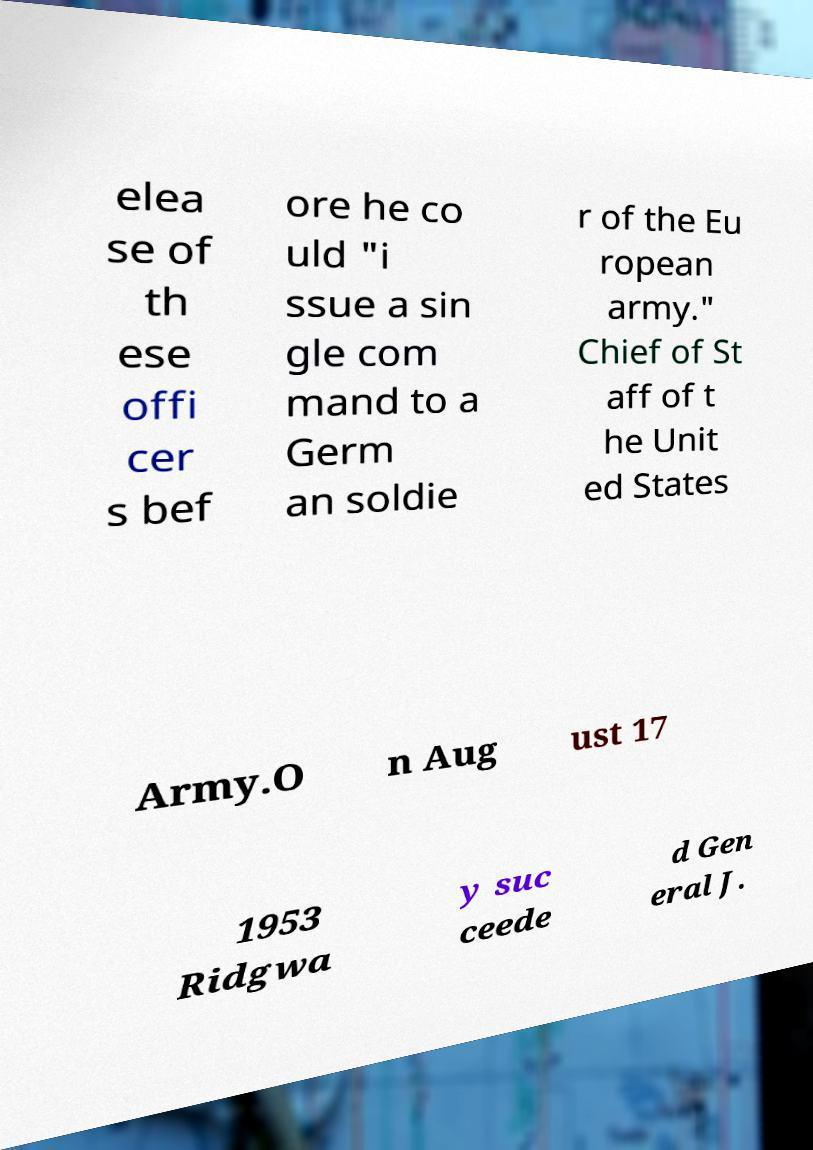What messages or text are displayed in this image? I need them in a readable, typed format. elea se of th ese offi cer s bef ore he co uld "i ssue a sin gle com mand to a Germ an soldie r of the Eu ropean army." Chief of St aff of t he Unit ed States Army.O n Aug ust 17 1953 Ridgwa y suc ceede d Gen eral J. 